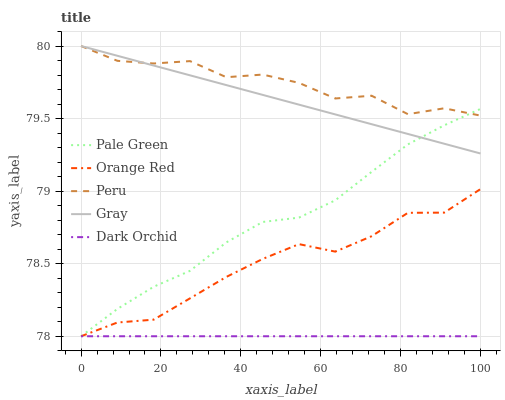Does Dark Orchid have the minimum area under the curve?
Answer yes or no. Yes. Does Peru have the maximum area under the curve?
Answer yes or no. Yes. Does Gray have the minimum area under the curve?
Answer yes or no. No. Does Gray have the maximum area under the curve?
Answer yes or no. No. Is Dark Orchid the smoothest?
Answer yes or no. Yes. Is Peru the roughest?
Answer yes or no. Yes. Is Gray the smoothest?
Answer yes or no. No. Is Gray the roughest?
Answer yes or no. No. Does Dark Orchid have the lowest value?
Answer yes or no. Yes. Does Gray have the lowest value?
Answer yes or no. No. Does Peru have the highest value?
Answer yes or no. Yes. Does Pale Green have the highest value?
Answer yes or no. No. Is Dark Orchid less than Peru?
Answer yes or no. Yes. Is Peru greater than Dark Orchid?
Answer yes or no. Yes. Does Dark Orchid intersect Pale Green?
Answer yes or no. Yes. Is Dark Orchid less than Pale Green?
Answer yes or no. No. Is Dark Orchid greater than Pale Green?
Answer yes or no. No. Does Dark Orchid intersect Peru?
Answer yes or no. No. 